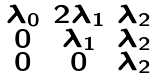Convert formula to latex. <formula><loc_0><loc_0><loc_500><loc_500>\begin{smallmatrix} \lambda _ { 0 } & 2 \lambda _ { 1 } & \lambda _ { 2 } \\ 0 & \lambda _ { 1 } & \lambda _ { 2 } \\ 0 & 0 & \lambda _ { 2 } \end{smallmatrix}</formula> 